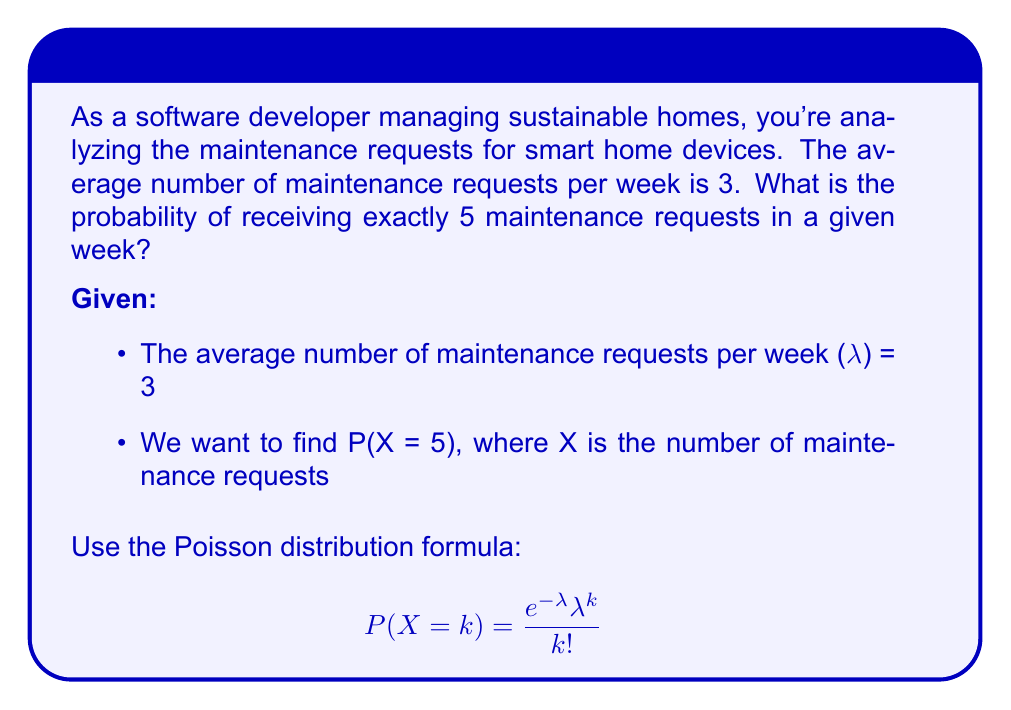Teach me how to tackle this problem. To solve this problem, we'll use the Poisson distribution formula:

$$P(X = k) = \frac{e^{-\lambda} \lambda^k}{k!}$$

Where:
- λ (lambda) is the average number of events in the given interval
- k is the number of events we're interested in
- e is Euler's number (approximately 2.71828)

Step 1: Identify the values
λ = 3 (average number of maintenance requests per week)
k = 5 (we want exactly 5 maintenance requests)

Step 2: Plug the values into the formula
$$P(X = 5) = \frac{e^{-3} 3^5}{5!}$$

Step 3: Calculate the numerator
- $e^{-3} \approx 0.0497871$
- $3^5 = 243$
- $e^{-3} \cdot 3^5 \approx 12.0984$

Step 4: Calculate the denominator
$5! = 5 \times 4 \times 3 \times 2 \times 1 = 120$

Step 5: Divide the numerator by the denominator
$$P(X = 5) \approx \frac{12.0984}{120} \approx 0.1008$$

Step 6: Convert to a percentage
0.1008 × 100% ≈ 10.08%
Answer: 10.08% 